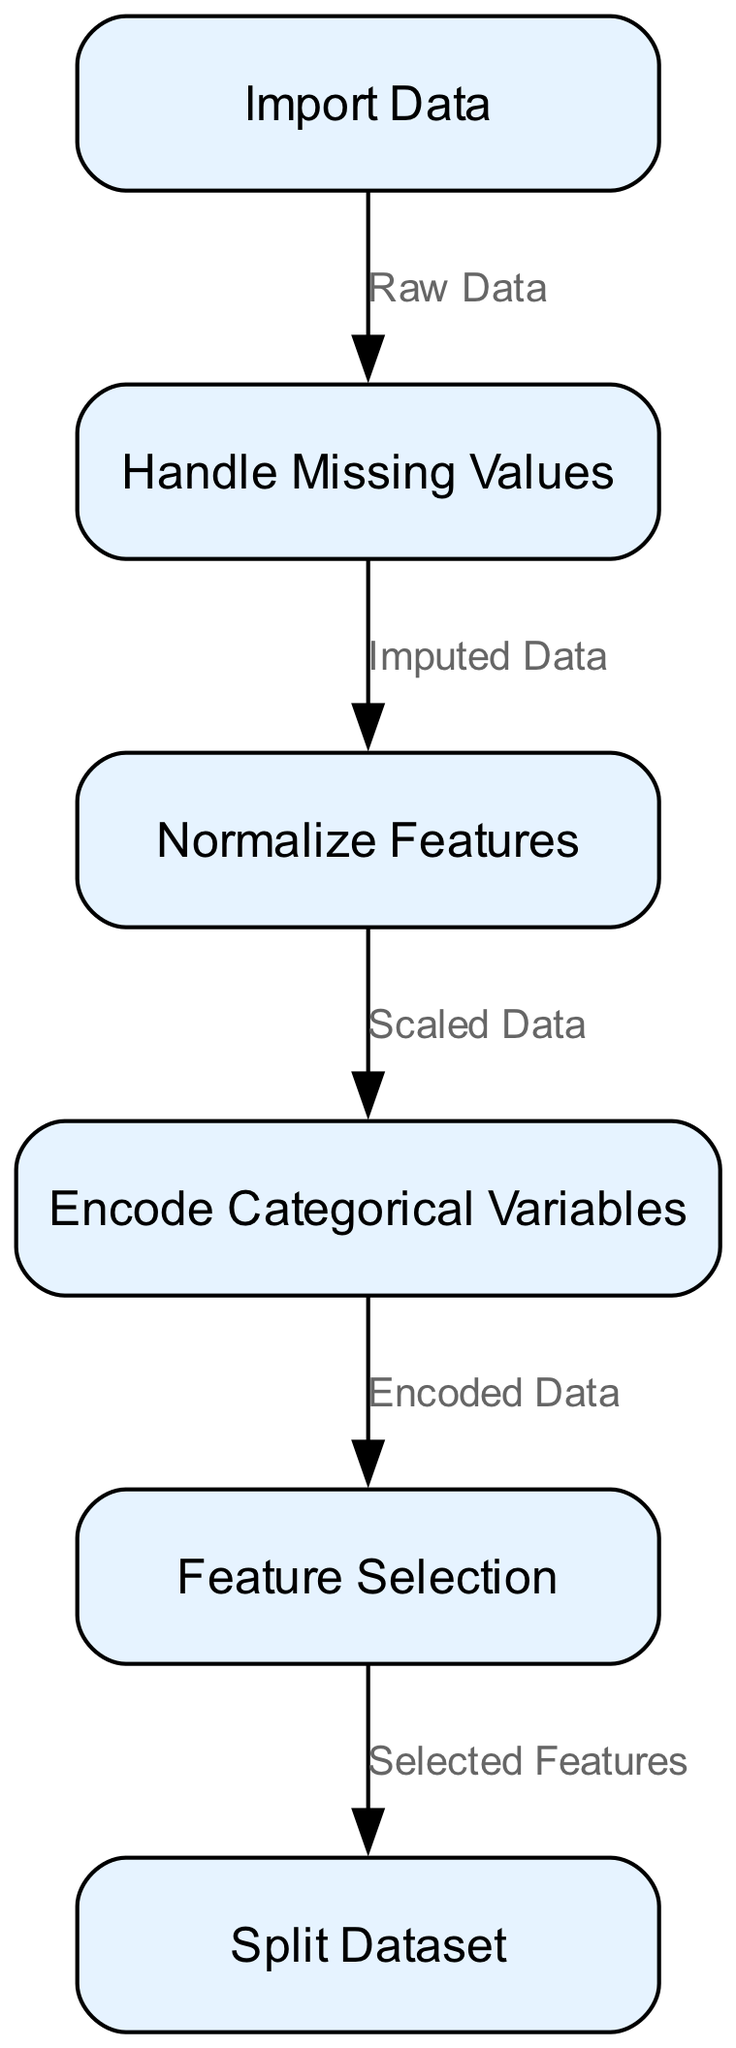What is the first node in the data preprocessing pipeline? The first node listed in the diagram is "Import Data," which is labeled as the starting point of the pipeline.
Answer: Import Data How many nodes are present in the diagram? By counting the nodes enumerated in the diagram, there are six nodes representing different steps in the data preprocessing pipeline.
Answer: 6 What is the last step before splitting the dataset? According to the edges in the diagram, "Feature Selection" is the step immediately preceding "Split Dataset."
Answer: Feature Selection Which node directly follows "Handle Missing Values"? The edge from "Handle Missing Values" points to "Normalize Features," indicating that it is the next step in the sequence.
Answer: Normalize Features What type of data comes into the "Handle Missing Values" node? The "Handle Missing Values" node receives "Raw Data," as indicated by the label on the edge leading into it.
Answer: Raw Data After normalizing features, what is the next step in the pipeline? The diagram shows that the immediate next step after normalizing the features is to "Encode Categorical Variables."
Answer: Encode Categorical Variables What is the relationship between "Encode Categorical Variables" and "Feature Selection"? The edge from "Encode Categorical Variables" to "Feature Selection" suggests that "Encoded Data" serves as input to "Feature Selection."
Answer: Encoded Data How many edges are drawn in the diagram? By counting the edges connecting the nodes in the diagram, we find there are five edges representing the flow through the steps of the pipeline.
Answer: 5 What is the output from the "Normalize Features" node? The label on the edge indicates that the output from "Normalize Features" is "Scaled Data," which becomes the input for the next node.
Answer: Scaled Data 